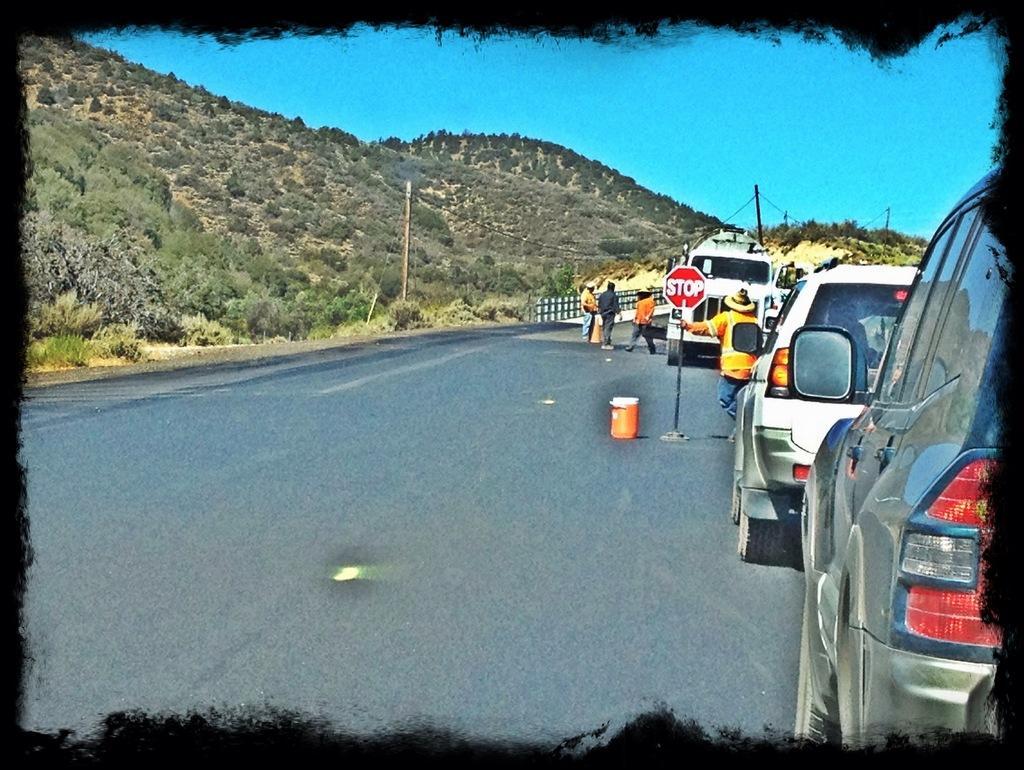Can you describe this image briefly? This is an edited picture. In the background we can see the sky. On the left side of the picture we can see the hills with thicket, current poles with wires and a railing. In this picture we can see the people on the road, cars and we can see a man wearing a hat and he is holding a sign board with his hand. We can see an orange object on the road. 